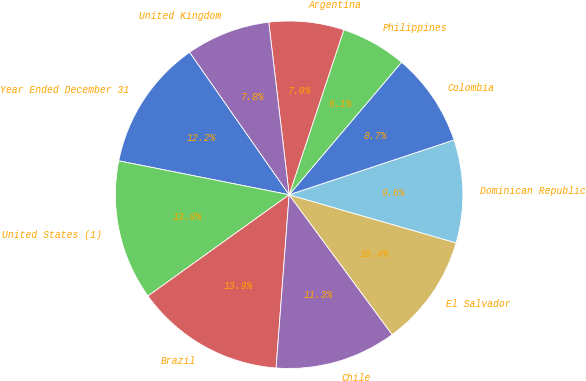<chart> <loc_0><loc_0><loc_500><loc_500><pie_chart><fcel>Year Ended December 31<fcel>United States (1)<fcel>Brazil<fcel>Chile<fcel>El Salvador<fcel>Dominican Republic<fcel>Colombia<fcel>Philippines<fcel>Argentina<fcel>United Kingdom<nl><fcel>12.17%<fcel>13.03%<fcel>13.9%<fcel>11.3%<fcel>10.43%<fcel>9.57%<fcel>8.7%<fcel>6.1%<fcel>6.97%<fcel>7.83%<nl></chart> 